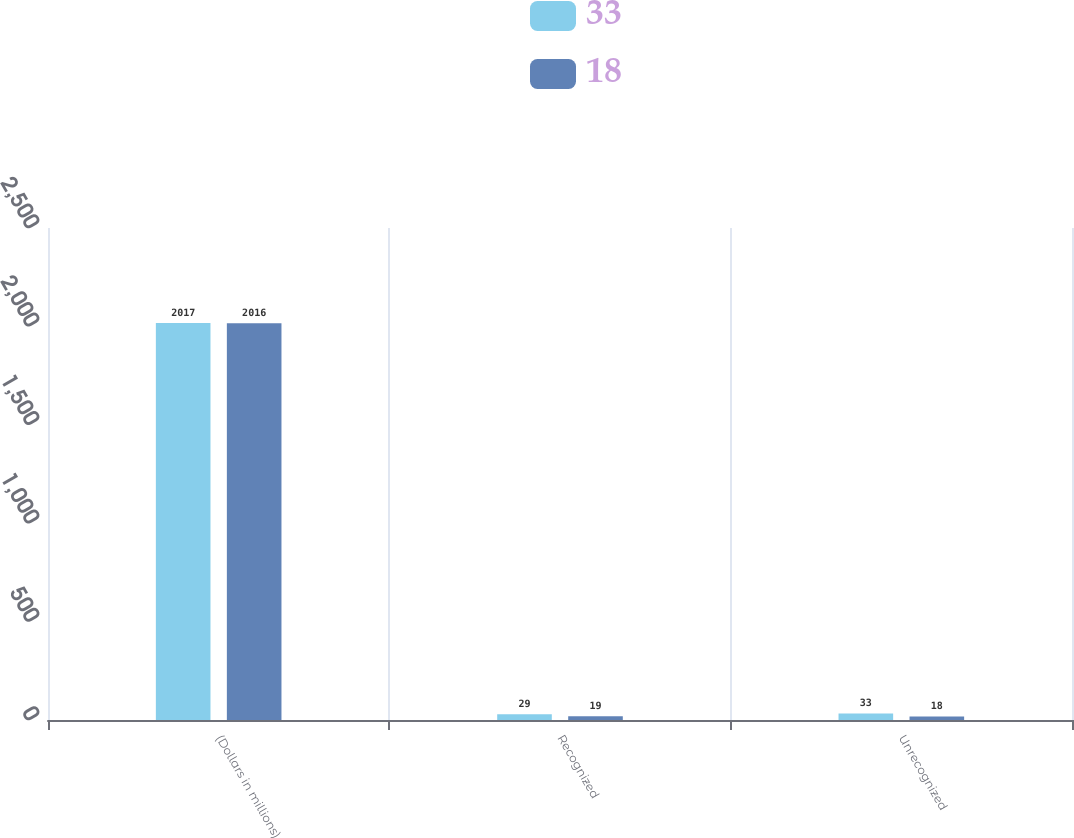Convert chart to OTSL. <chart><loc_0><loc_0><loc_500><loc_500><stacked_bar_chart><ecel><fcel>(Dollars in millions)<fcel>Recognized<fcel>Unrecognized<nl><fcel>33<fcel>2017<fcel>29<fcel>33<nl><fcel>18<fcel>2016<fcel>19<fcel>18<nl></chart> 